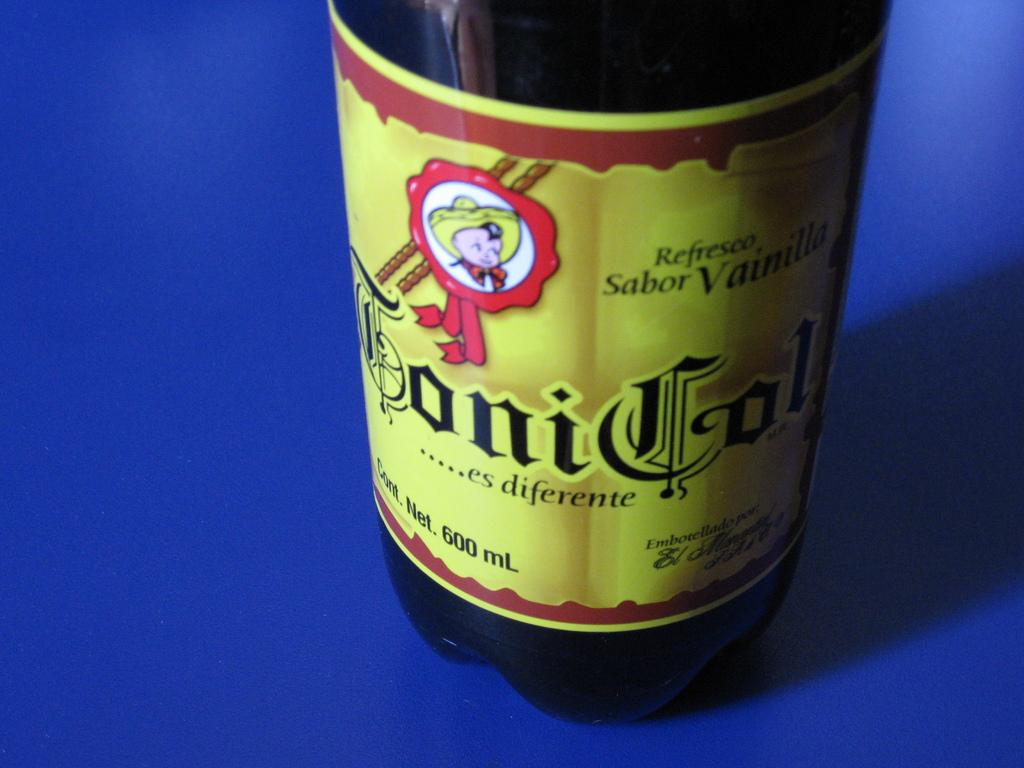Provide a one-sentence caption for the provided image. A bottle with a child wearing a sombrero on it indicates it is vanilla flavored. 